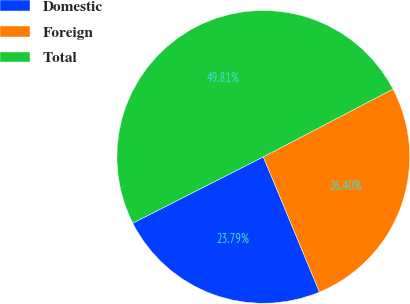Convert chart to OTSL. <chart><loc_0><loc_0><loc_500><loc_500><pie_chart><fcel>Domestic<fcel>Foreign<fcel>Total<nl><fcel>23.79%<fcel>26.4%<fcel>49.81%<nl></chart> 